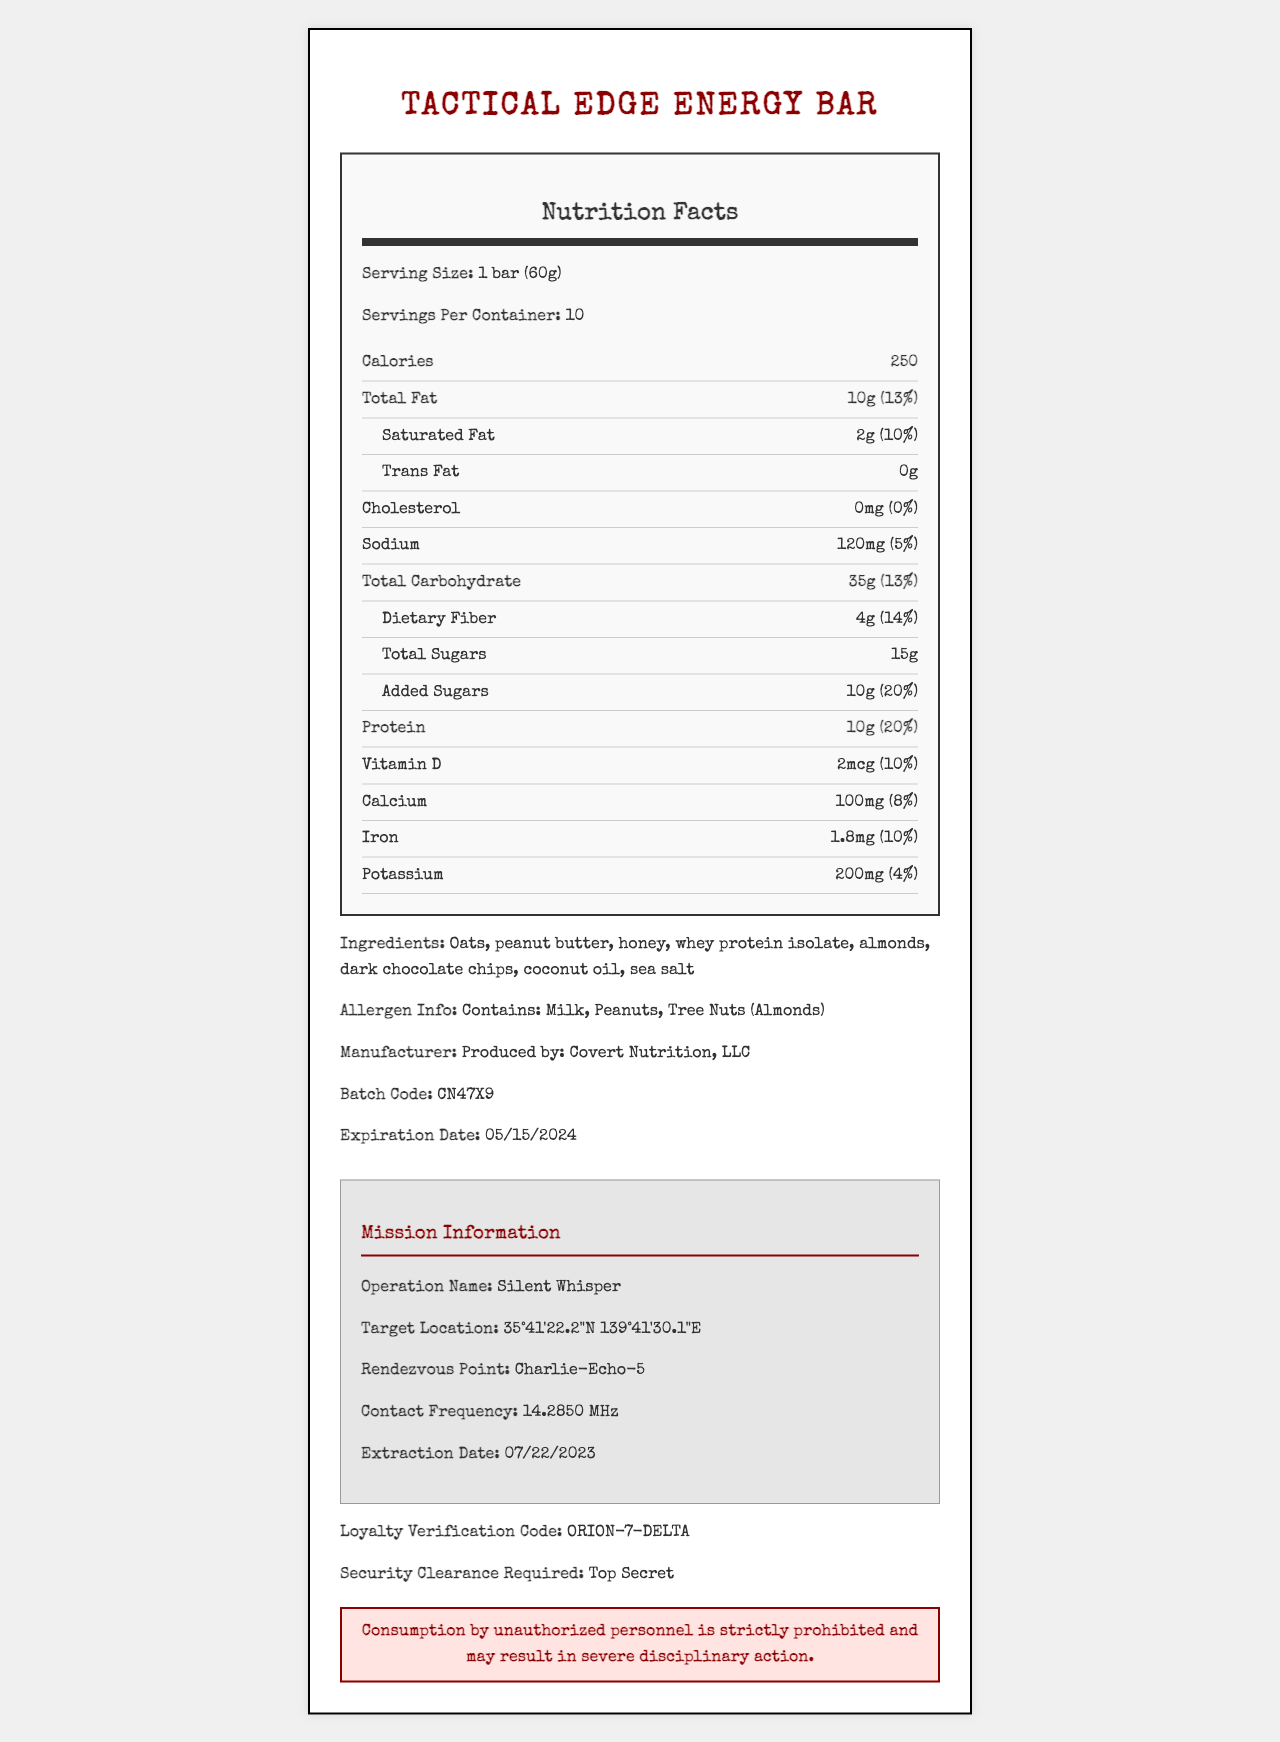what is the serving size for the Tactical Edge Energy Bar? The serving size is specified as "1 bar (60g)" in the label.
Answer: 1 bar (60g) how many calories are there per serving? The calories per serving are listed as 250 on the nutrition label.
Answer: 250 how much total fat and its percent daily value are in one serving? The total fat content in one serving is 10g, and the percent daily value is 13%, both of which are mentioned in the nutrition label.
Answer: 10g (13%) what are the ingredients in the energy bar? The ingredients are listed in the document under the ingredients section: "Oats, peanut butter, honey, whey protein isolate, almonds, dark chocolate chips, coconut oil, sea salt".
Answer: Oats, peanut butter, honey, whey protein isolate, almonds, dark chocolate chips, coconut oil, sea salt who is the manufacturer of the Tactical Edge Energy Bar? The manufacturer information is given as "Produced by: Covert Nutrition, LLC".
Answer: Covert Nutrition, LLC what is the loyalty verification code? The loyalty verification code mentioned in the document is "ORION-7-DELTA".
Answer: ORION-7-DELTA what is the extraction date for the operation Silent Whisper? The extraction date for the mission as mentioned in the mission information is "07/22/2023".
Answer: 07/22/2023 what is the contact frequency for the mission? The contact frequency mentioned in the mission information is "14.2850 MHz".
Answer: 14.2850 MHz how much protein is in each serving? Each serving contains 10g of protein, and it provides 20% of the daily value for protein.
Answer: 10g (20%) what allergens does the Tactical Edge Energy Bar contain? The allergens listed in the document are "Milk, Peanuts, Tree Nuts (Almonds)".
Answer: Milk, Peanuts, Tree Nuts (Almonds) when does the Tactical Edge Energy Bar expire? The expiration date provided in the document is "05/15/2024".
Answer: 05/15/2024 where is the target location for the operation Silent Whisper? The target location for the mission is listed as "35°41'22.2\"N 139°41'30.1\"E".
Answer: 35°41'22.2\"N 139°41'30.1\"E what is the security clearance required to access the information in the document? The document specifies that the required security clearance is "Top Secret".
Answer: Top Secret what is the percent daily value of vitamin D in one serving? The percent daily value of vitamin D in one serving is 10%.
Answer: 10% which of the following is NOT an ingredient in the Tactical Edge Energy Bar? A. Oats B. Peanut butter C. Soy protein D. Dark chocolate chips The listed ingredients are "Oats, peanut butter, honey, whey protein isolate, almonds, dark chocolate chips, coconut oil, sea salt". Soy protein is not included.
Answer: C which vitamin has the highest percent daily value per serving? I. Vitamin D II. Calcium III. Iron Vitamin D with 10% per serving has the highest percent daily value compared to Calcium (8%) and Iron (10%).
Answer: I is the Tactical Edge Energy Bar high in trans fat? The nutrition label indicates there are 0g of trans fat per serving.
Answer: No summarize the main idea of the document The document presents both nutritional details about the energy bar and sensitive mission-related information, ensuring only authorized personnel should consume or use it.
Answer: Tactical Edge Energy Bar is a high-protein energy bar produced by Covert Nutrition, LLC. It includes detailed nutritional information, ingredients, allergens, and coded mission information related to an operation named Silent Whisper, with high-level security and loyalty verification codes. how was the image of the document generated? The document does not provide details on how the image was generated, only the visual content of the rendered nutrition facts and mission information.
Answer: Not enough information 